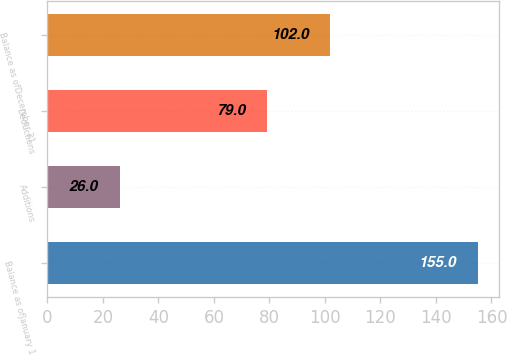<chart> <loc_0><loc_0><loc_500><loc_500><bar_chart><fcel>Balance as ofJanuary 1<fcel>Additions<fcel>Deductions<fcel>Balance as ofDecember 31<nl><fcel>155<fcel>26<fcel>79<fcel>102<nl></chart> 